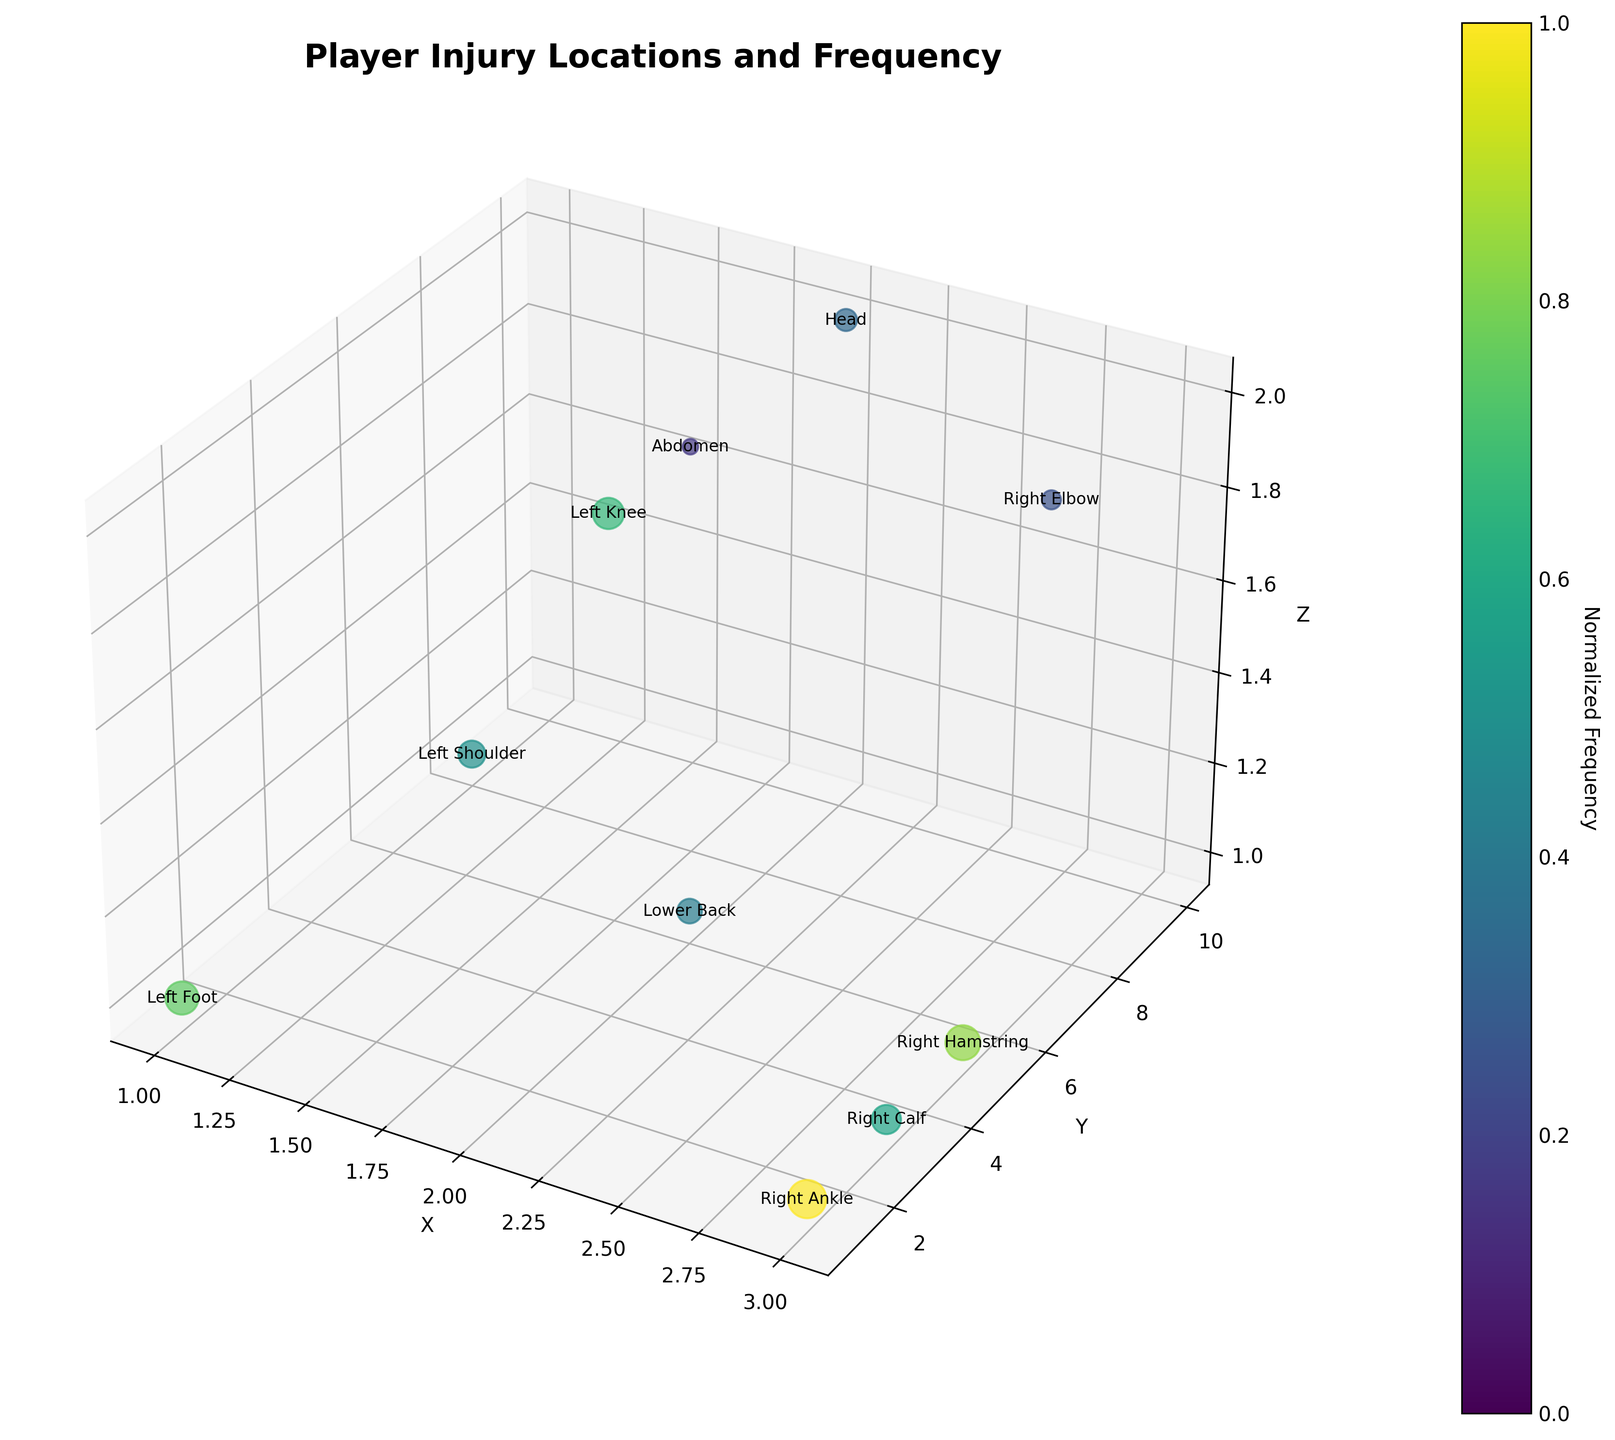How many injury data points are plotted in the figure? By counting the number of unique body parts labeled on the plot, you can determine the number of distinct injury points.
Answer: 10 What color represents the highest injury frequency in the plot? The highest injury frequency is indicated by the most intense color on the viridis color map used in the plot.
Answer: Dark purple Which body part has the highest injury frequency and which player does it belong to? The body part with the largest scatter size represents the highest injury frequency. According to the frequency data, this corresponds to Lionel Messi's right ankle.
Answer: Right Ankle, Lionel Messi What is the normalized frequency value of Cristiano Ronaldo's left knee injury? To get the normalized value, divide Ronaldo's injury frequency by the maximum frequency and look for the respective shade on the color scale.
Answer: 0.67 Which player has the lowest injury frequency, and what is the injury type? The player associated with the smallest scatter size has the lowest frequency. By comparing frequencies, we find Harry Kane has the lowest frequency with an elbow contusion.
Answer: Harry Kane, Contusion Arrange the players' injury frequencies in ascending order. Compare each player's injury frequency numerically and arrange them from the smallest to the largest value: Harry Kane (3), Virgil van Dijk (2), Kevin De Bruyne (4), Neymar Jr. (5), Robert Lewandowski (6), Erling Haaland (7), Cristiano Ronaldo (8), Mohamed Salah (9), Kylian Mbappé (10), Lionel Messi (12).
Answer: 2, 3, 4, 5, 6, 7, 8, 9, 10, 12 Which players have injuries on the 'Z=1' coordinate, and what are their respective frequencies? Identify the scattered points with a 'Z' coordinate of 1 and refer to their frequencies: Lionel Messi, Kylian Mbappé, Neymar Jr., Robert Lewandowski, and Erling Haaland.
Answer: Lionel Messi (12), Kylian Mbappé (10), Neymar Jr. (5), Robert Lewandowski (6), Erling Haaland (7) Is the average frequency of injuries higher for injuries located on the 'Z=2' coordinate than overall? Calculate the average frequency for 'Z=2' (Cristiano Ronaldo (8), Kevin De Bruyne (4), Harry Kane (3), Virgil van Dijk (2)) and compare it with the overall average: (8+4+3+2)/4 = 4.25. The overall average is (12+8+5+10+6+7+4+9+3+2)/10 = 6.6.
Answer: No, 4.25 < 6.6 